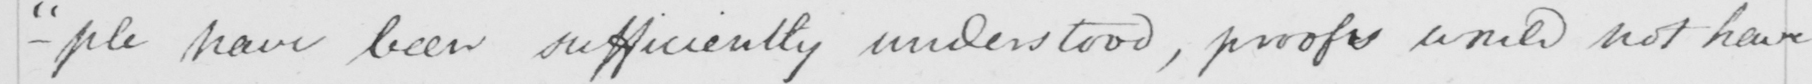Transcribe the text shown in this historical manuscript line. - " ple have been sufficiently understood , proofs would not have 